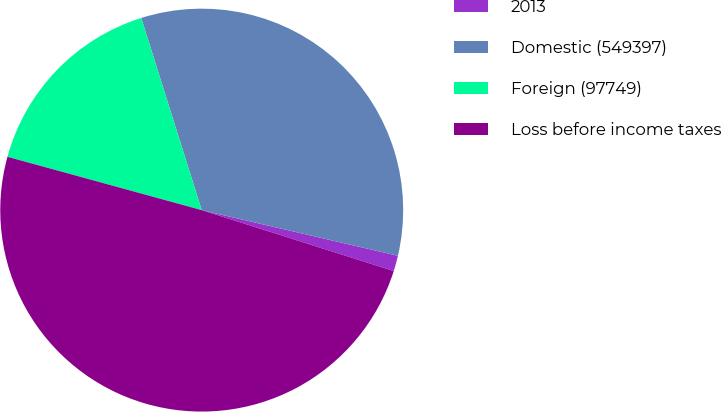Convert chart. <chart><loc_0><loc_0><loc_500><loc_500><pie_chart><fcel>2013<fcel>Domestic (549397)<fcel>Foreign (97749)<fcel>Loss before income taxes<nl><fcel>1.25%<fcel>33.49%<fcel>15.88%<fcel>49.37%<nl></chart> 